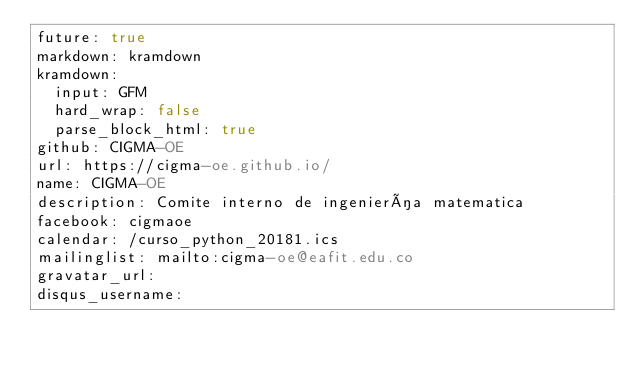<code> <loc_0><loc_0><loc_500><loc_500><_YAML_>future: true
markdown: kramdown
kramdown:
  input: GFM
  hard_wrap: false
  parse_block_html: true
github: CIGMA-OE
url: https://cigma-oe.github.io/
name: CIGMA-OE
description: Comite interno de ingeniería matematica
facebook: cigmaoe
calendar: /curso_python_20181.ics
mailinglist: mailto:cigma-oe@eafit.edu.co
gravatar_url:
disqus_username:
</code> 